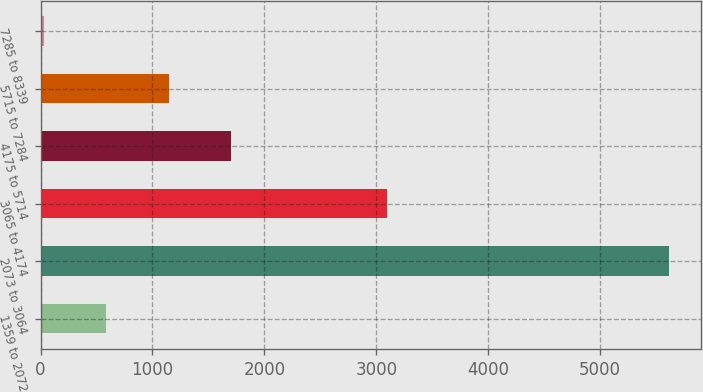Convert chart to OTSL. <chart><loc_0><loc_0><loc_500><loc_500><bar_chart><fcel>1359 to 2072<fcel>2073 to 3064<fcel>3065 to 4174<fcel>4175 to 5714<fcel>5715 to 7284<fcel>7285 to 8339<nl><fcel>587.2<fcel>5620<fcel>3100<fcel>1705.6<fcel>1146.4<fcel>28<nl></chart> 